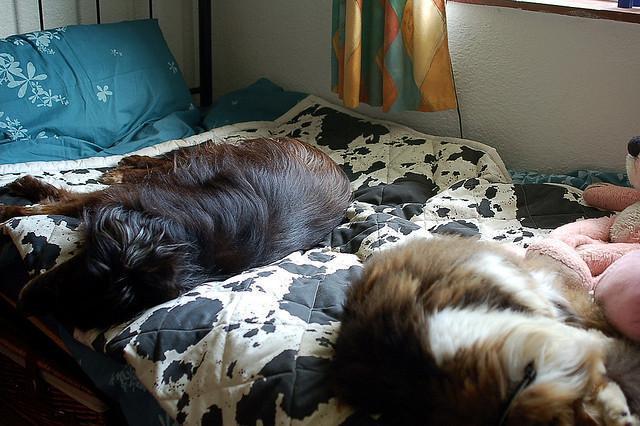Who is the bed for?
From the following set of four choices, select the accurate answer to respond to the question.
Options: Human, rhino, elephant, dogs. Human. 